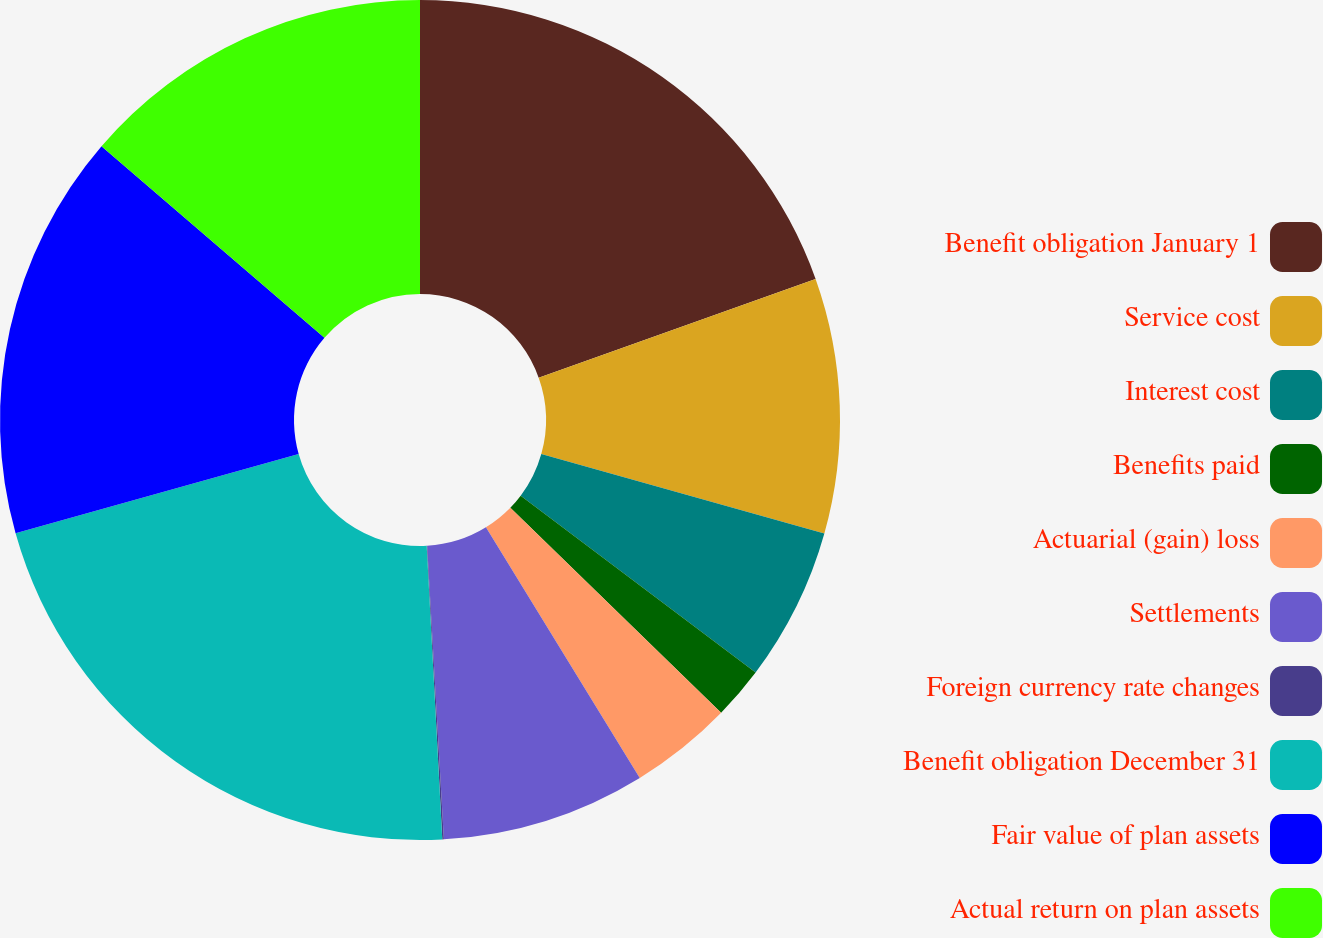<chart> <loc_0><loc_0><loc_500><loc_500><pie_chart><fcel>Benefit obligation January 1<fcel>Service cost<fcel>Interest cost<fcel>Benefits paid<fcel>Actuarial (gain) loss<fcel>Settlements<fcel>Foreign currency rate changes<fcel>Benefit obligation December 31<fcel>Fair value of plan assets<fcel>Actual return on plan assets<nl><fcel>19.55%<fcel>9.81%<fcel>5.91%<fcel>2.01%<fcel>3.96%<fcel>7.86%<fcel>0.06%<fcel>21.5%<fcel>15.65%<fcel>13.7%<nl></chart> 